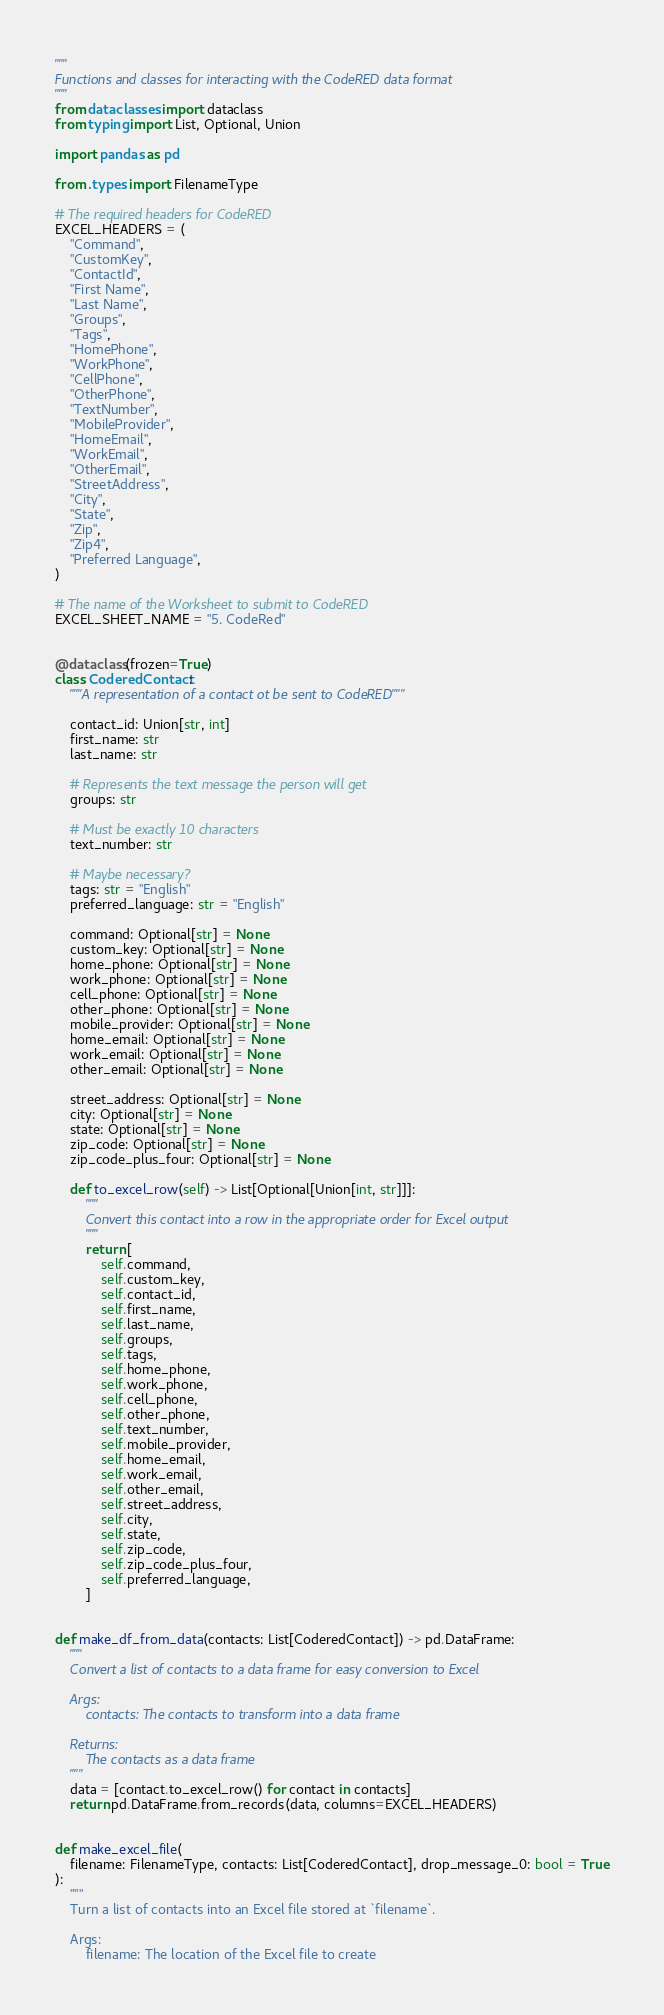Convert code to text. <code><loc_0><loc_0><loc_500><loc_500><_Python_>"""
Functions and classes for interacting with the CodeRED data format
"""
from dataclasses import dataclass
from typing import List, Optional, Union

import pandas as pd

from .types import FilenameType

# The required headers for CodeRED
EXCEL_HEADERS = (
    "Command",
    "CustomKey",
    "ContactId",
    "First Name",
    "Last Name",
    "Groups",
    "Tags",
    "HomePhone",
    "WorkPhone",
    "CellPhone",
    "OtherPhone",
    "TextNumber",
    "MobileProvider",
    "HomeEmail",
    "WorkEmail",
    "OtherEmail",
    "StreetAddress",
    "City",
    "State",
    "Zip",
    "Zip4",
    "Preferred Language",
)

# The name of the Worksheet to submit to CodeRED
EXCEL_SHEET_NAME = "5. CodeRed"


@dataclass(frozen=True)
class CoderedContact:
    """A representation of a contact ot be sent to CodeRED"""

    contact_id: Union[str, int]
    first_name: str
    last_name: str

    # Represents the text message the person will get
    groups: str

    # Must be exactly 10 characters
    text_number: str

    # Maybe necessary?
    tags: str = "English"
    preferred_language: str = "English"

    command: Optional[str] = None
    custom_key: Optional[str] = None
    home_phone: Optional[str] = None
    work_phone: Optional[str] = None
    cell_phone: Optional[str] = None
    other_phone: Optional[str] = None
    mobile_provider: Optional[str] = None
    home_email: Optional[str] = None
    work_email: Optional[str] = None
    other_email: Optional[str] = None

    street_address: Optional[str] = None
    city: Optional[str] = None
    state: Optional[str] = None
    zip_code: Optional[str] = None
    zip_code_plus_four: Optional[str] = None

    def to_excel_row(self) -> List[Optional[Union[int, str]]]:
        """
        Convert this contact into a row in the appropriate order for Excel output
        """
        return [
            self.command,
            self.custom_key,
            self.contact_id,
            self.first_name,
            self.last_name,
            self.groups,
            self.tags,
            self.home_phone,
            self.work_phone,
            self.cell_phone,
            self.other_phone,
            self.text_number,
            self.mobile_provider,
            self.home_email,
            self.work_email,
            self.other_email,
            self.street_address,
            self.city,
            self.state,
            self.zip_code,
            self.zip_code_plus_four,
            self.preferred_language,
        ]


def make_df_from_data(contacts: List[CoderedContact]) -> pd.DataFrame:
    """
    Convert a list of contacts to a data frame for easy conversion to Excel

    Args:
        contacts: The contacts to transform into a data frame

    Returns:
        The contacts as a data frame
    """
    data = [contact.to_excel_row() for contact in contacts]
    return pd.DataFrame.from_records(data, columns=EXCEL_HEADERS)


def make_excel_file(
    filename: FilenameType, contacts: List[CoderedContact], drop_message_0: bool = True
):
    """
    Turn a list of contacts into an Excel file stored at `filename`.

    Args:
        filename: The location of the Excel file to create</code> 